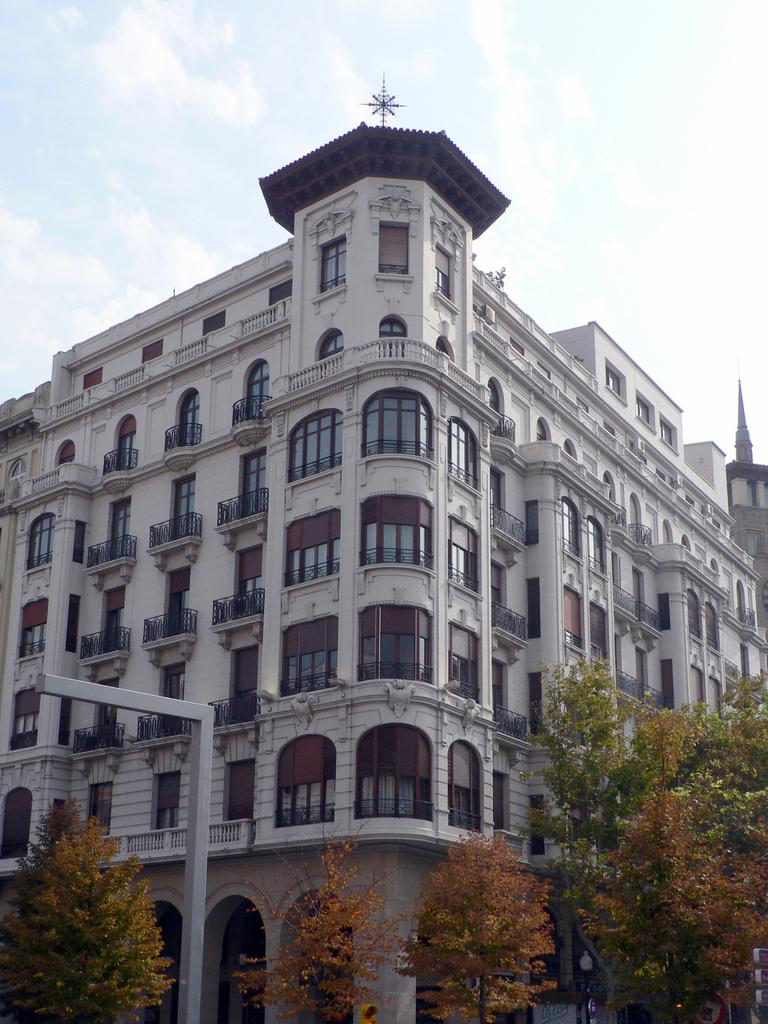What type of structure is present in the image? There is a building in the image. What features can be observed on the building? The building has windows and a railing. What type of vegetation is visible in the image? There are green and brown color trees in the image. What is the color of the sky in the image? The sky is blue and white in color. Where is the cushion placed in the image? There is no cushion present in the image. What is the hand doing in the image? There are no hands visible in the image. 